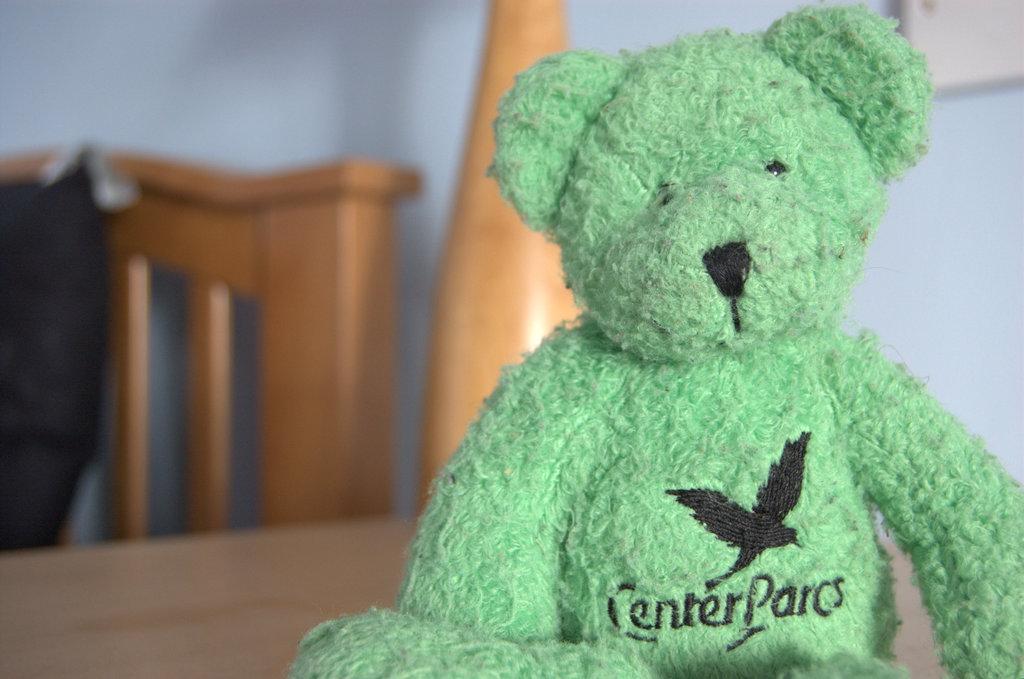Could you give a brief overview of what you see in this image? In this picture we can see a teddy on the surface. Behind the teddy, it looks like a chair and there are some objects and a wall. 